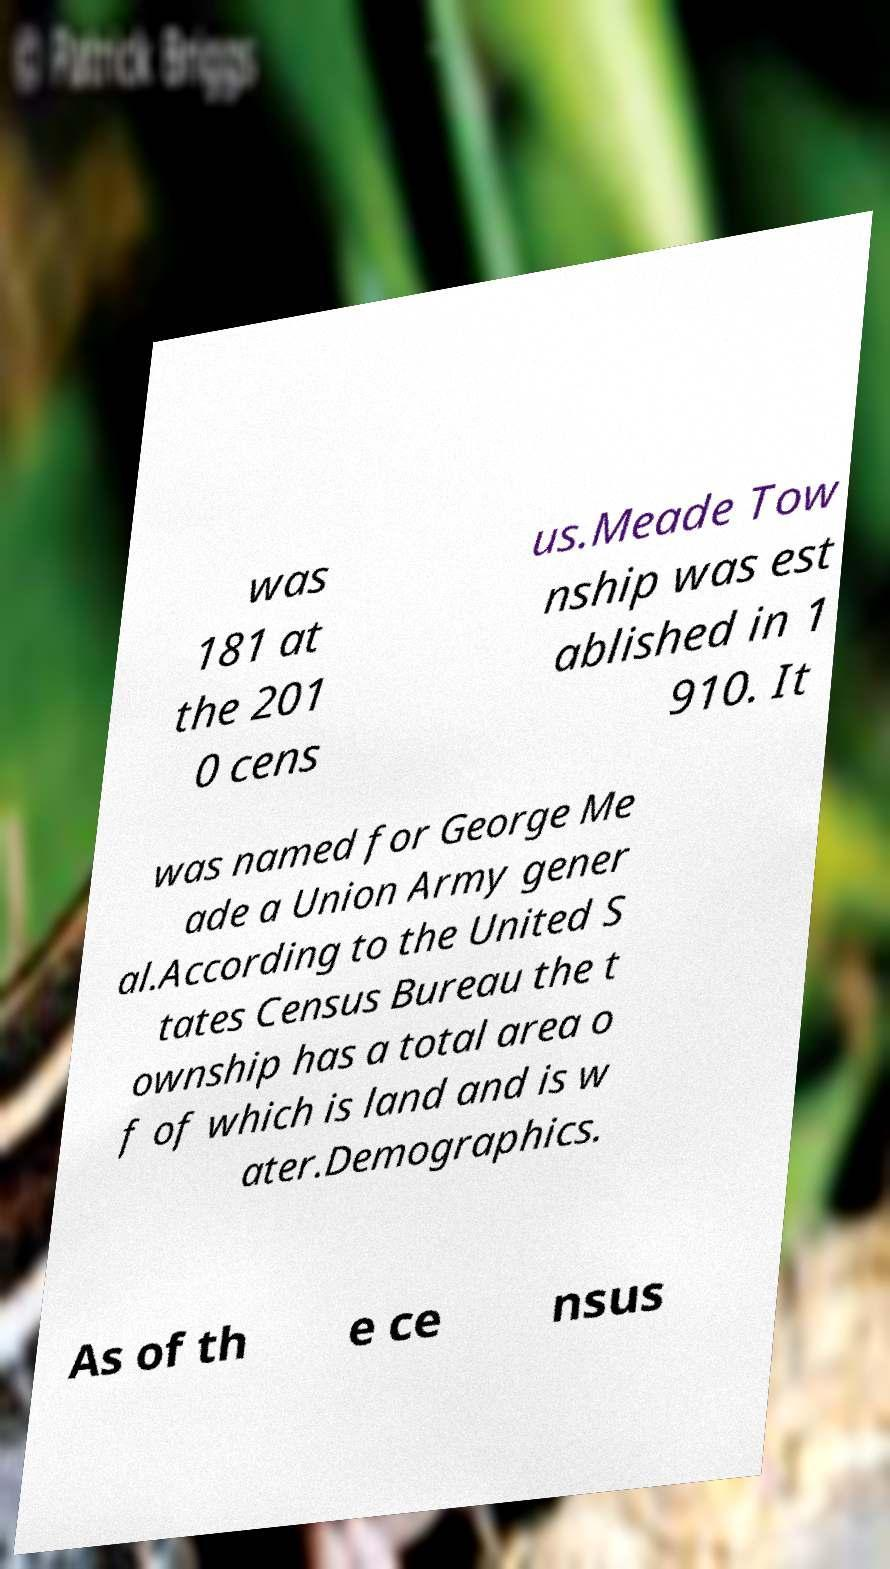Please read and relay the text visible in this image. What does it say? was 181 at the 201 0 cens us.Meade Tow nship was est ablished in 1 910. It was named for George Me ade a Union Army gener al.According to the United S tates Census Bureau the t ownship has a total area o f of which is land and is w ater.Demographics. As of th e ce nsus 